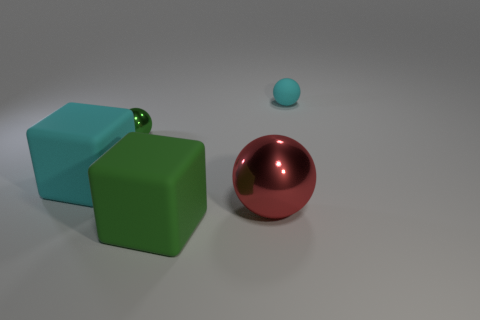How does the lighting in the image affect the appearance of the objects? The lighting in the image casts soft shadows and highlights on the objects, enhancing their three-dimensionality. The reflective surfaces of the metallic objects, in particular, demonstrate the direction and intensity of the light source. 